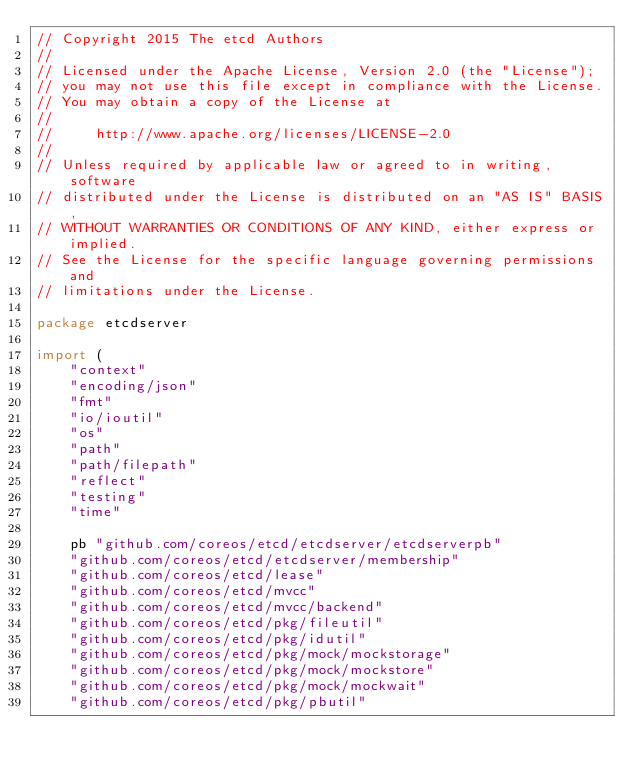Convert code to text. <code><loc_0><loc_0><loc_500><loc_500><_Go_>// Copyright 2015 The etcd Authors
//
// Licensed under the Apache License, Version 2.0 (the "License");
// you may not use this file except in compliance with the License.
// You may obtain a copy of the License at
//
//     http://www.apache.org/licenses/LICENSE-2.0
//
// Unless required by applicable law or agreed to in writing, software
// distributed under the License is distributed on an "AS IS" BASIS,
// WITHOUT WARRANTIES OR CONDITIONS OF ANY KIND, either express or implied.
// See the License for the specific language governing permissions and
// limitations under the License.

package etcdserver

import (
	"context"
	"encoding/json"
	"fmt"
	"io/ioutil"
	"os"
	"path"
	"path/filepath"
	"reflect"
	"testing"
	"time"

	pb "github.com/coreos/etcd/etcdserver/etcdserverpb"
	"github.com/coreos/etcd/etcdserver/membership"
	"github.com/coreos/etcd/lease"
	"github.com/coreos/etcd/mvcc"
	"github.com/coreos/etcd/mvcc/backend"
	"github.com/coreos/etcd/pkg/fileutil"
	"github.com/coreos/etcd/pkg/idutil"
	"github.com/coreos/etcd/pkg/mock/mockstorage"
	"github.com/coreos/etcd/pkg/mock/mockstore"
	"github.com/coreos/etcd/pkg/mock/mockwait"
	"github.com/coreos/etcd/pkg/pbutil"</code> 